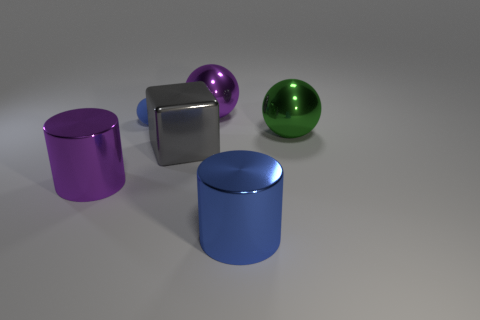What shape is the metallic thing that is behind the big gray metal block and in front of the purple metal ball?
Your answer should be very brief. Sphere. Is there a green sphere made of the same material as the big gray cube?
Provide a short and direct response. Yes. There is a metal object that is the same color as the rubber object; what is its size?
Provide a short and direct response. Large. What color is the shiny cylinder that is in front of the purple metallic cylinder?
Offer a terse response. Blue. Does the tiny blue object have the same shape as the purple metal object behind the large purple metallic cylinder?
Provide a short and direct response. Yes. Is there another large metallic cube of the same color as the metallic block?
Provide a succinct answer. No. What is the size of the purple cylinder that is the same material as the green thing?
Offer a very short reply. Large. Does the small object have the same color as the block?
Your answer should be very brief. No. Does the purple metallic thing that is right of the large purple cylinder have the same shape as the large blue metal thing?
Offer a terse response. No. How many cylinders have the same size as the blue sphere?
Your answer should be very brief. 0. 